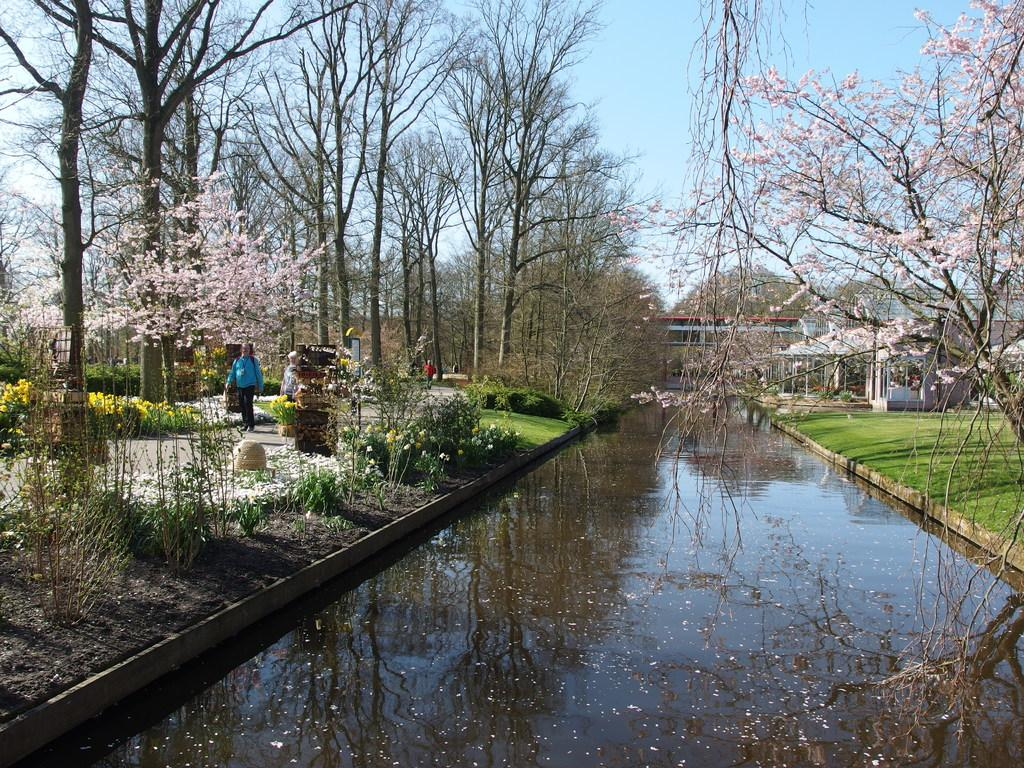What type of natural environment is depicted in the image? The image contains grass, water, plants, trees, and the sky, which suggests a natural environment. What type of structures can be seen in the image? There are buildings in the image. What is the person in the image doing? The person is standing on the ground in the image. What else can be seen in the image besides the natural environment and structures? There are some objects in the image. What type of pipe is being played by the person in the image? There is no pipe present in the image; the person is simply standing on the ground. What time of day is it in the image, considering it's an afternoon scene? The time of day cannot be determined from the image, as there is no indication of the time. 